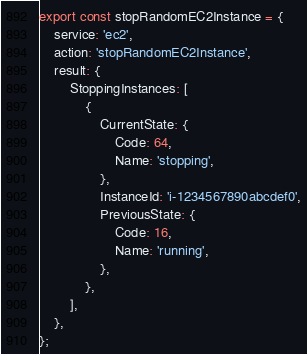Convert code to text. <code><loc_0><loc_0><loc_500><loc_500><_TypeScript_>export const stopRandomEC2Instance = {
    service: 'ec2',
    action: 'stopRandomEC2Instance',
    result: {
        StoppingInstances: [
            {
                CurrentState: {
                    Code: 64,
                    Name: 'stopping',
                },
                InstanceId: 'i-1234567890abcdef0',
                PreviousState: {
                    Code: 16,
                    Name: 'running',
                },
            },
        ],
    },
};
</code> 